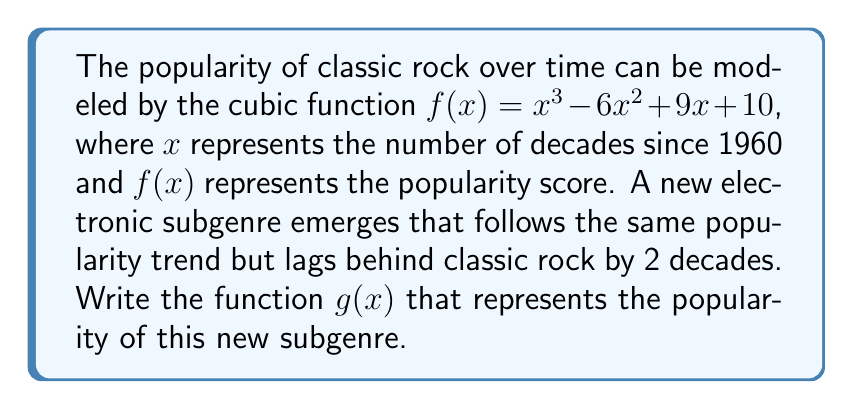Could you help me with this problem? To solve this problem, we need to translate the original function $f(x)$ horizontally to the right by 2 units. This shift represents the 2-decade lag of the new subgenre compared to classic rock.

Steps:
1. The general form for a horizontal translation of a function $f(x)$ by $h$ units to the right is:
   $g(x) = f(x - h)$

2. In this case, $h = 2$ (representing 2 decades), so we replace $x$ with $(x - 2)$ in the original function:

   $g(x) = f(x - 2)$
   $g(x) = (x - 2)^3 - 6(x - 2)^2 + 9(x - 2) + 10$

3. Expand the cubic term:
   $(x - 2)^3 = x^3 - 6x^2 + 12x - 8$

4. Expand the quadratic term:
   $-6(x - 2)^2 = -6(x^2 - 4x + 4) = -6x^2 + 24x - 24$

5. Expand the linear term:
   $9(x - 2) = 9x - 18$

6. Combine all terms:
   $g(x) = (x^3 - 6x^2 + 12x - 8) + (-6x^2 + 24x - 24) + (9x - 18) + 10$
   $g(x) = x^3 - 12x^2 + 45x - 40$

Therefore, the function representing the popularity of the new electronic subgenre is $g(x) = x^3 - 12x^2 + 45x - 40$.
Answer: $g(x) = x^3 - 12x^2 + 45x - 40$ 